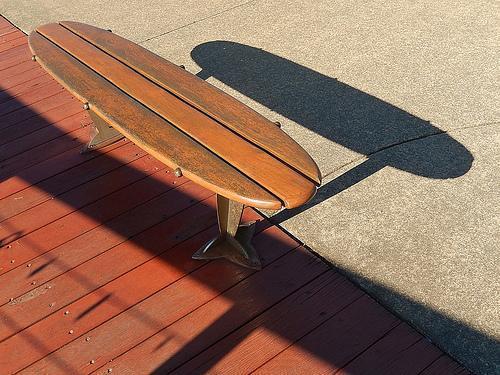How many benches?
Give a very brief answer. 1. 